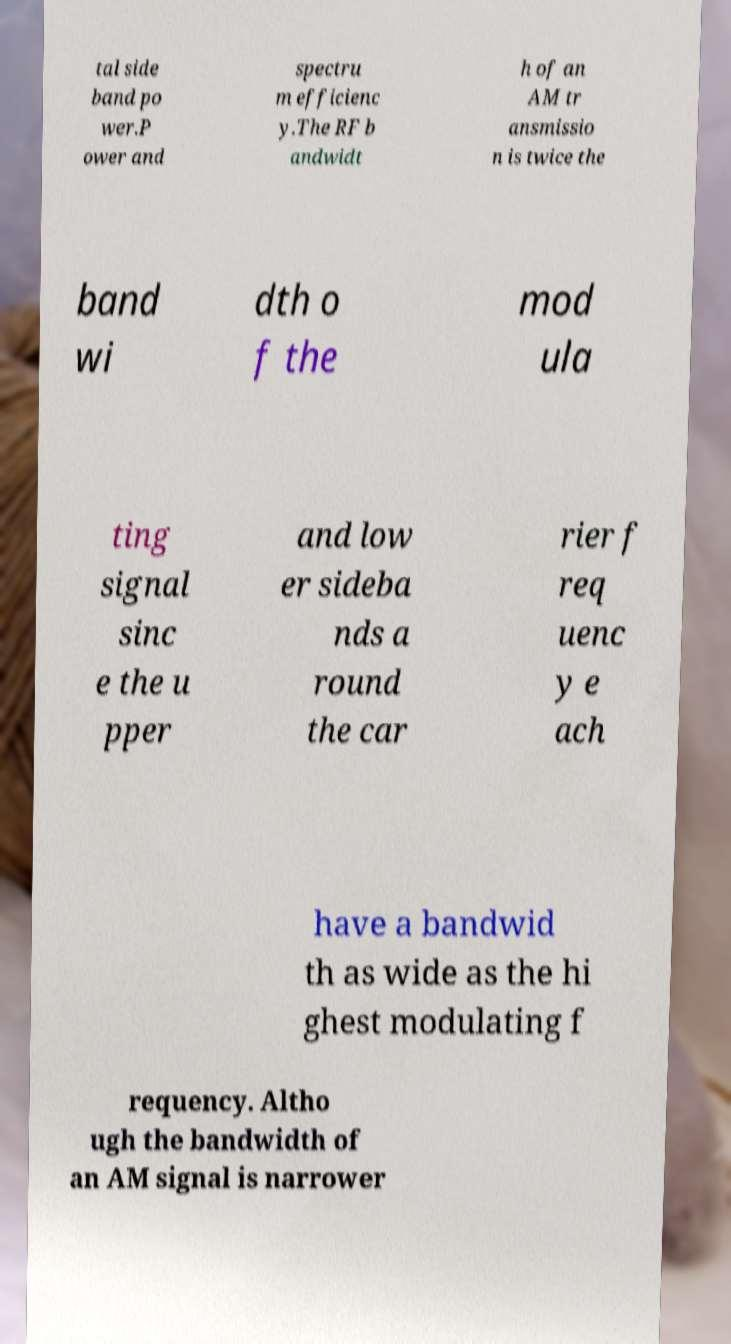There's text embedded in this image that I need extracted. Can you transcribe it verbatim? tal side band po wer.P ower and spectru m efficienc y.The RF b andwidt h of an AM tr ansmissio n is twice the band wi dth o f the mod ula ting signal sinc e the u pper and low er sideba nds a round the car rier f req uenc y e ach have a bandwid th as wide as the hi ghest modulating f requency. Altho ugh the bandwidth of an AM signal is narrower 